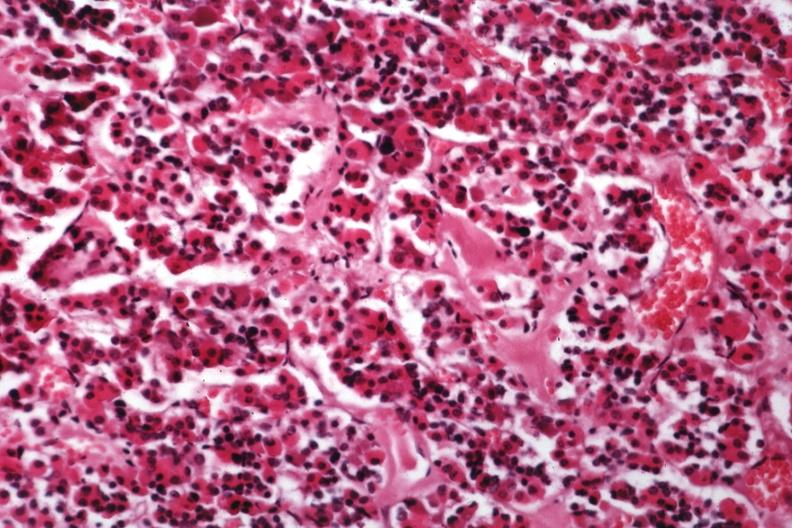where is this part in the figure?
Answer the question using a single word or phrase. Endocrine system 